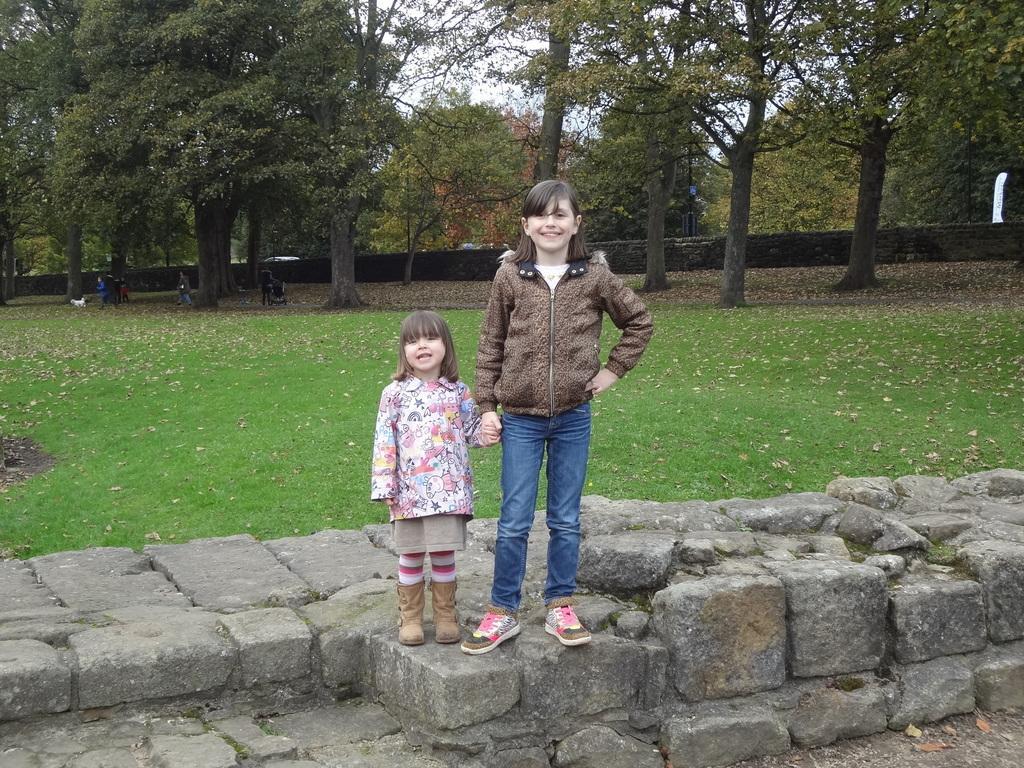How would you summarize this image in a sentence or two? In this image, we can see two kids wearing clothes and standing on rocks. There is a grass on the ground which is in the middle of the image. There are some trees at the top of the image. 